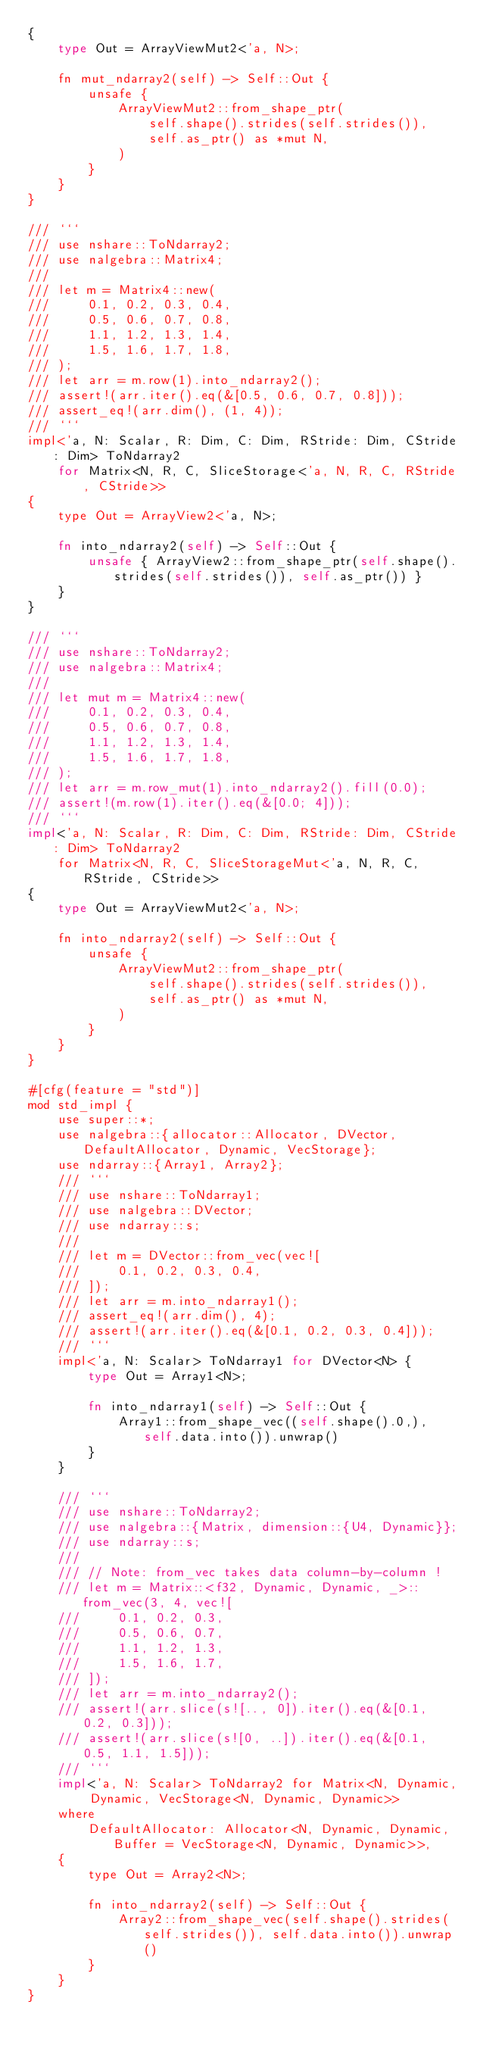<code> <loc_0><loc_0><loc_500><loc_500><_Rust_>{
    type Out = ArrayViewMut2<'a, N>;

    fn mut_ndarray2(self) -> Self::Out {
        unsafe {
            ArrayViewMut2::from_shape_ptr(
                self.shape().strides(self.strides()),
                self.as_ptr() as *mut N,
            )
        }
    }
}

/// ```
/// use nshare::ToNdarray2;
/// use nalgebra::Matrix4;
///
/// let m = Matrix4::new(
///     0.1, 0.2, 0.3, 0.4,
///     0.5, 0.6, 0.7, 0.8,
///     1.1, 1.2, 1.3, 1.4,
///     1.5, 1.6, 1.7, 1.8,
/// );
/// let arr = m.row(1).into_ndarray2();
/// assert!(arr.iter().eq(&[0.5, 0.6, 0.7, 0.8]));
/// assert_eq!(arr.dim(), (1, 4));
/// ```
impl<'a, N: Scalar, R: Dim, C: Dim, RStride: Dim, CStride: Dim> ToNdarray2
    for Matrix<N, R, C, SliceStorage<'a, N, R, C, RStride, CStride>>
{
    type Out = ArrayView2<'a, N>;

    fn into_ndarray2(self) -> Self::Out {
        unsafe { ArrayView2::from_shape_ptr(self.shape().strides(self.strides()), self.as_ptr()) }
    }
}

/// ```
/// use nshare::ToNdarray2;
/// use nalgebra::Matrix4;
///
/// let mut m = Matrix4::new(
///     0.1, 0.2, 0.3, 0.4,
///     0.5, 0.6, 0.7, 0.8,
///     1.1, 1.2, 1.3, 1.4,
///     1.5, 1.6, 1.7, 1.8,
/// );
/// let arr = m.row_mut(1).into_ndarray2().fill(0.0);
/// assert!(m.row(1).iter().eq(&[0.0; 4]));
/// ```
impl<'a, N: Scalar, R: Dim, C: Dim, RStride: Dim, CStride: Dim> ToNdarray2
    for Matrix<N, R, C, SliceStorageMut<'a, N, R, C, RStride, CStride>>
{
    type Out = ArrayViewMut2<'a, N>;

    fn into_ndarray2(self) -> Self::Out {
        unsafe {
            ArrayViewMut2::from_shape_ptr(
                self.shape().strides(self.strides()),
                self.as_ptr() as *mut N,
            )
        }
    }
}

#[cfg(feature = "std")]
mod std_impl {
    use super::*;
    use nalgebra::{allocator::Allocator, DVector, DefaultAllocator, Dynamic, VecStorage};
    use ndarray::{Array1, Array2};
    /// ```
    /// use nshare::ToNdarray1;
    /// use nalgebra::DVector;
    /// use ndarray::s;
    ///
    /// let m = DVector::from_vec(vec![
    ///     0.1, 0.2, 0.3, 0.4,
    /// ]);
    /// let arr = m.into_ndarray1();
    /// assert_eq!(arr.dim(), 4);
    /// assert!(arr.iter().eq(&[0.1, 0.2, 0.3, 0.4]));
    /// ```
    impl<'a, N: Scalar> ToNdarray1 for DVector<N> {
        type Out = Array1<N>;

        fn into_ndarray1(self) -> Self::Out {
            Array1::from_shape_vec((self.shape().0,), self.data.into()).unwrap()
        }
    }

    /// ```
    /// use nshare::ToNdarray2;
    /// use nalgebra::{Matrix, dimension::{U4, Dynamic}};
    /// use ndarray::s;
    ///
    /// // Note: from_vec takes data column-by-column !
    /// let m = Matrix::<f32, Dynamic, Dynamic, _>::from_vec(3, 4, vec![
    ///     0.1, 0.2, 0.3,
    ///     0.5, 0.6, 0.7,
    ///     1.1, 1.2, 1.3,
    ///     1.5, 1.6, 1.7,
    /// ]);
    /// let arr = m.into_ndarray2();
    /// assert!(arr.slice(s![.., 0]).iter().eq(&[0.1, 0.2, 0.3]));
    /// assert!(arr.slice(s![0, ..]).iter().eq(&[0.1, 0.5, 1.1, 1.5]));
    /// ```
    impl<'a, N: Scalar> ToNdarray2 for Matrix<N, Dynamic, Dynamic, VecStorage<N, Dynamic, Dynamic>>
    where
        DefaultAllocator: Allocator<N, Dynamic, Dynamic, Buffer = VecStorage<N, Dynamic, Dynamic>>,
    {
        type Out = Array2<N>;

        fn into_ndarray2(self) -> Self::Out {
            Array2::from_shape_vec(self.shape().strides(self.strides()), self.data.into()).unwrap()
        }
    }
}
</code> 